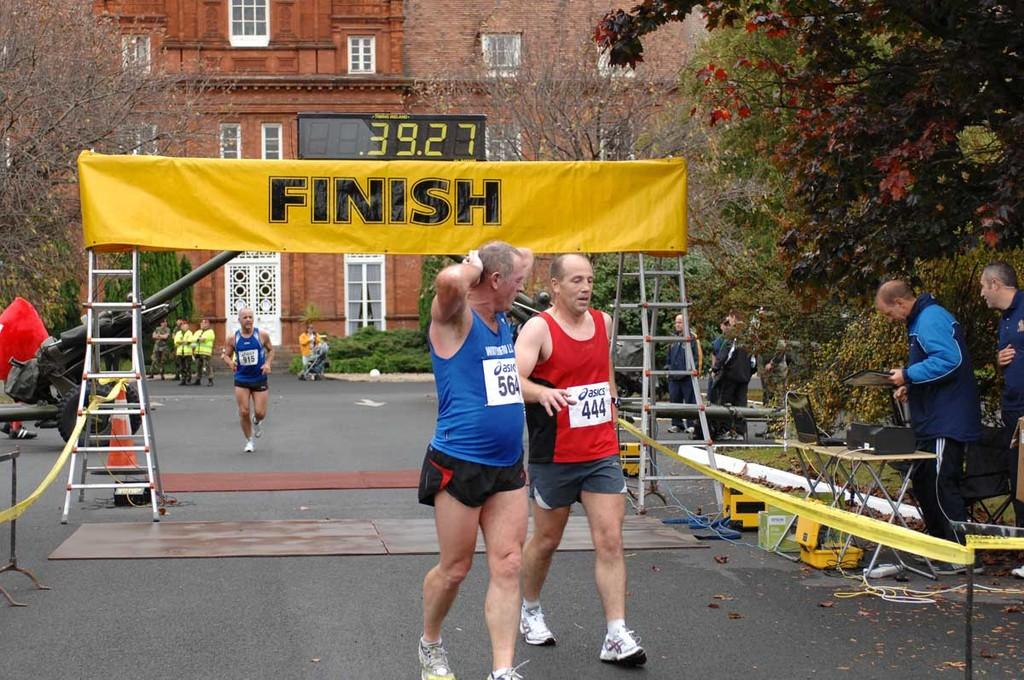What are the two people in the foreground of the image doing? The two people are walking in the foreground of the image. What can be seen in the middle of the image? There is a finish line board in the middle of the image. What type of vegetation is on the right side of the image? There are trees on the right side of the image. What is the size of the bed in the image? There is no bed present in the image. What discovery was made by the two people walking in the foreground of the image? The image does not provide information about any discoveries made by the two people walking. 